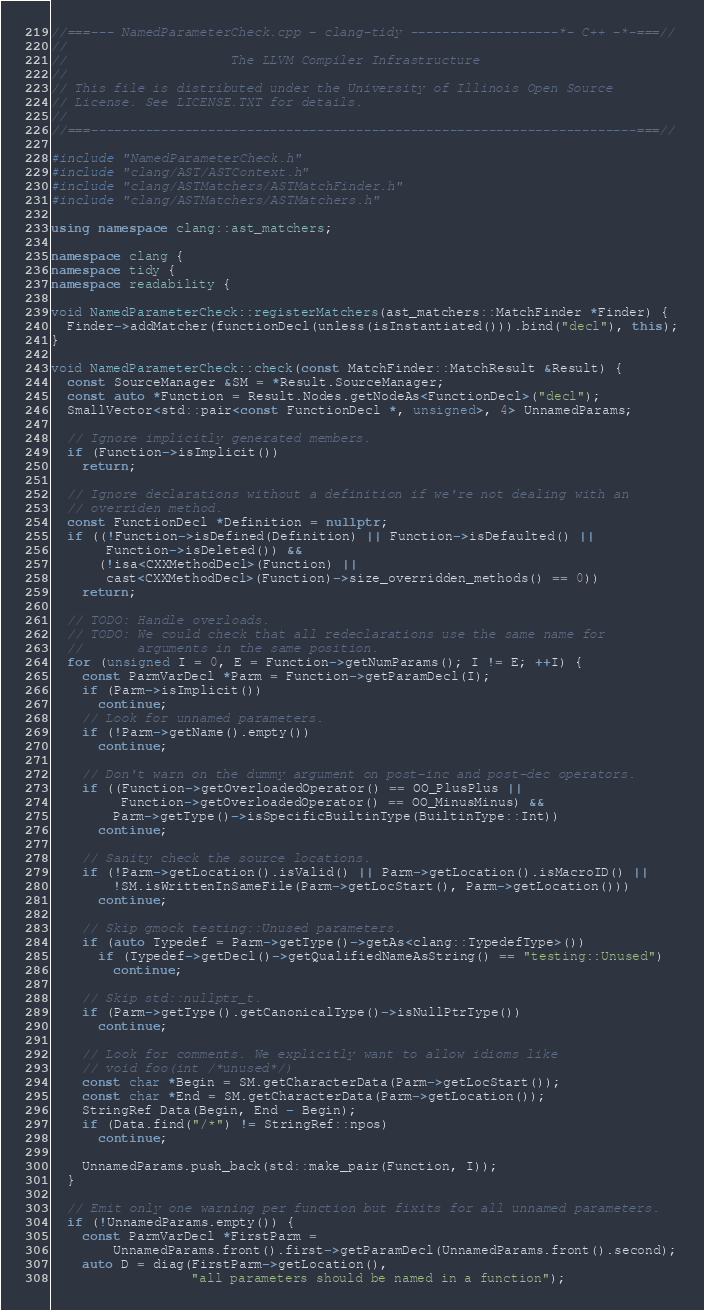Convert code to text. <code><loc_0><loc_0><loc_500><loc_500><_C++_>//===--- NamedParameterCheck.cpp - clang-tidy -------------------*- C++ -*-===//
//
//                     The LLVM Compiler Infrastructure
//
// This file is distributed under the University of Illinois Open Source
// License. See LICENSE.TXT for details.
//
//===----------------------------------------------------------------------===//

#include "NamedParameterCheck.h"
#include "clang/AST/ASTContext.h"
#include "clang/ASTMatchers/ASTMatchFinder.h"
#include "clang/ASTMatchers/ASTMatchers.h"

using namespace clang::ast_matchers;

namespace clang {
namespace tidy {
namespace readability {

void NamedParameterCheck::registerMatchers(ast_matchers::MatchFinder *Finder) {
  Finder->addMatcher(functionDecl(unless(isInstantiated())).bind("decl"), this);
}

void NamedParameterCheck::check(const MatchFinder::MatchResult &Result) {
  const SourceManager &SM = *Result.SourceManager;
  const auto *Function = Result.Nodes.getNodeAs<FunctionDecl>("decl");
  SmallVector<std::pair<const FunctionDecl *, unsigned>, 4> UnnamedParams;

  // Ignore implicitly generated members.
  if (Function->isImplicit())
    return;

  // Ignore declarations without a definition if we're not dealing with an
  // overriden method.
  const FunctionDecl *Definition = nullptr;
  if ((!Function->isDefined(Definition) || Function->isDefaulted() ||
       Function->isDeleted()) &&
      (!isa<CXXMethodDecl>(Function) ||
       cast<CXXMethodDecl>(Function)->size_overridden_methods() == 0))
    return;

  // TODO: Handle overloads.
  // TODO: We could check that all redeclarations use the same name for
  //       arguments in the same position.
  for (unsigned I = 0, E = Function->getNumParams(); I != E; ++I) {
    const ParmVarDecl *Parm = Function->getParamDecl(I);
    if (Parm->isImplicit())
      continue;
    // Look for unnamed parameters.
    if (!Parm->getName().empty())
      continue;

    // Don't warn on the dummy argument on post-inc and post-dec operators.
    if ((Function->getOverloadedOperator() == OO_PlusPlus ||
         Function->getOverloadedOperator() == OO_MinusMinus) &&
        Parm->getType()->isSpecificBuiltinType(BuiltinType::Int))
      continue;

    // Sanity check the source locations.
    if (!Parm->getLocation().isValid() || Parm->getLocation().isMacroID() ||
        !SM.isWrittenInSameFile(Parm->getLocStart(), Parm->getLocation()))
      continue;

    // Skip gmock testing::Unused parameters.
    if (auto Typedef = Parm->getType()->getAs<clang::TypedefType>())
      if (Typedef->getDecl()->getQualifiedNameAsString() == "testing::Unused")
        continue;

    // Skip std::nullptr_t.
    if (Parm->getType().getCanonicalType()->isNullPtrType())
      continue;

    // Look for comments. We explicitly want to allow idioms like
    // void foo(int /*unused*/)
    const char *Begin = SM.getCharacterData(Parm->getLocStart());
    const char *End = SM.getCharacterData(Parm->getLocation());
    StringRef Data(Begin, End - Begin);
    if (Data.find("/*") != StringRef::npos)
      continue;

    UnnamedParams.push_back(std::make_pair(Function, I));
  }

  // Emit only one warning per function but fixits for all unnamed parameters.
  if (!UnnamedParams.empty()) {
    const ParmVarDecl *FirstParm =
        UnnamedParams.front().first->getParamDecl(UnnamedParams.front().second);
    auto D = diag(FirstParm->getLocation(),
                  "all parameters should be named in a function");
</code> 